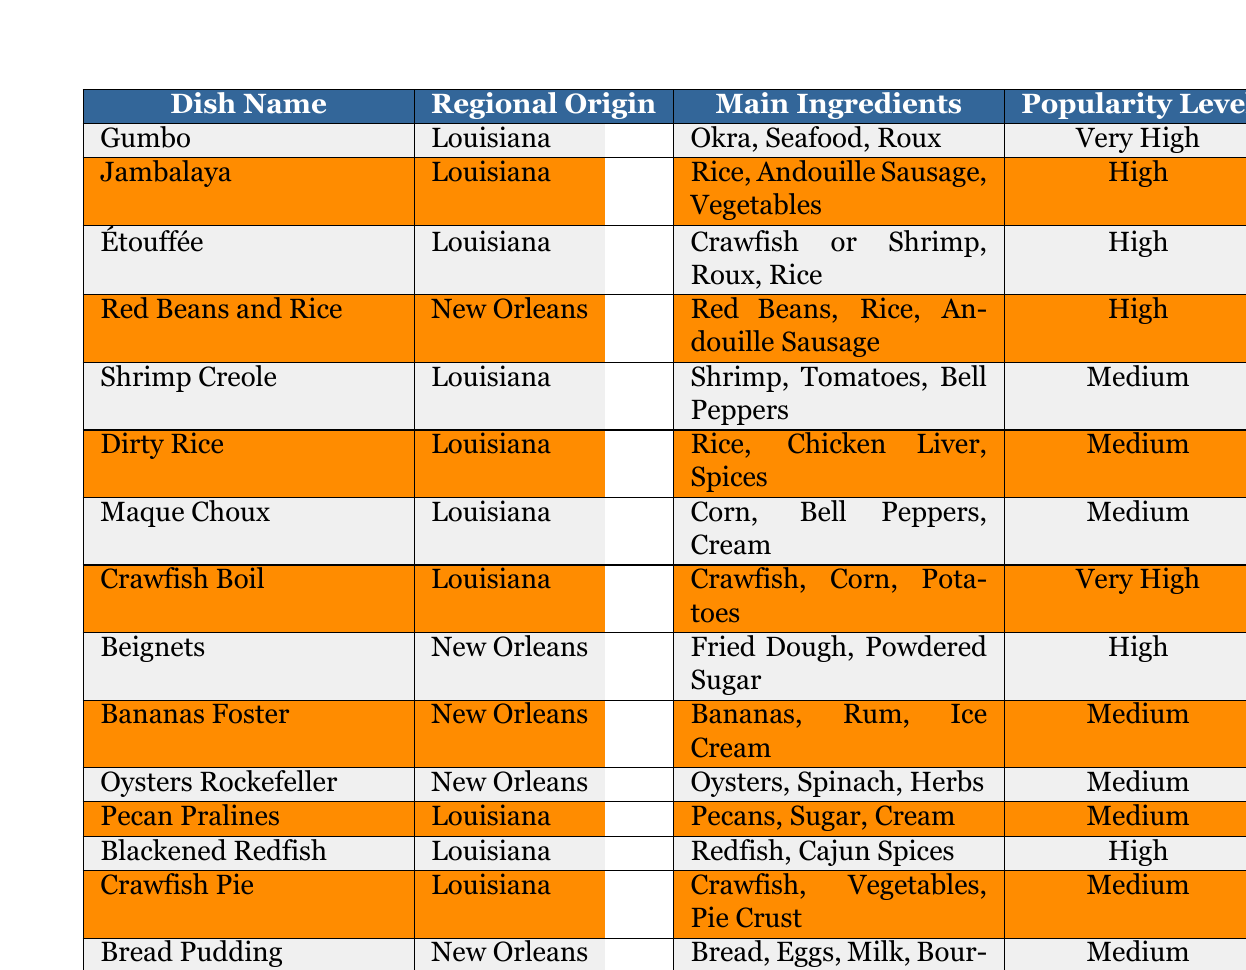What is the regional origin of Jambalaya? Jambalaya is listed in the table with its regional origin specified as Louisiana.
Answer: Louisiana Which dish has the highest popularity level? The dishes with the highest popularity level are Gumbo and Crawfish Boil, both are labeled as "Very High."
Answer: Gumbo and Crawfish Boil How many dishes are from New Orleans? By counting the rows where the regional origin is listed as New Orleans, there are 5 dishes: Red Beans and Rice, Beignets, Bananas Foster, Oysters Rockefeller, and Bread Pudding.
Answer: 5 What main ingredient is common in both Shrimp Creole and Étouffée? Both Shrimp Creole and Étouffée share shrimp as a main ingredient.
Answer: Shrimp Is there a dish with a medium popularity level that includes corn as an ingredient? Yes, Maque Choux and Crawfish Boil both have corn as an ingredient and are classified with varying popularity levels, but only Maque Choux as "Medium."
Answer: Yes How many dishes include rice as a main ingredient? The dishes that include rice are Jambalaya, Étouffée, Red Beans and Rice, Dirty Rice, and Crawfish Pie, totaling to five.
Answer: 5 What is the popularity level of Oysters Rockefeller? The popularity level of Oysters Rockefeller is categorized as "Medium" according to the table.
Answer: Medium Which dish contains both crawfish and a pie crust? The dish that contains crawfish and a pie crust is Crawfish Pie as stated in the main ingredients column.
Answer: Crawfish Pie How does the popularity of beignets compare to that of Bananas Foster? Beignets have a "High" popularity level, while Bananas Foster has a "Medium" popularity level, indicating that beignets are more popular.
Answer: Beignets are more popular Which Louisiana dish contains okra? Gumbo is the Louisiana dish that includes okra as one of its main ingredients.
Answer: Gumbo Are there any dishes with a popularity level of “Very High” that do not include seafood? Yes, Crawfish Boil has a "Very High" popularity level and includes crawfish, which is considered seafood. However, all drinks listed with such popularity appear to include seafood.
Answer: No 